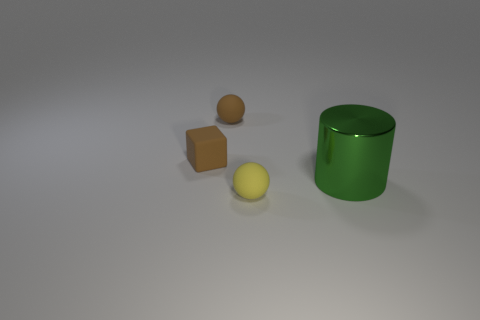What is the shape of the green metal thing?
Ensure brevity in your answer.  Cylinder. What number of blue blocks have the same size as the yellow matte thing?
Offer a terse response. 0. There is a tiny sphere that is in front of the cube; is there a matte sphere that is to the left of it?
Offer a terse response. Yes. What number of green objects are either metal cubes or balls?
Offer a very short reply. 0. What color is the big shiny thing?
Your response must be concise. Green. The brown object that is made of the same material as the small brown sphere is what size?
Ensure brevity in your answer.  Small. How many small brown matte objects have the same shape as the green shiny object?
Give a very brief answer. 0. Are there any other things that are the same size as the metal thing?
Keep it short and to the point. No. There is a cylinder in front of the brown rubber sphere behind the small yellow rubber ball; how big is it?
Ensure brevity in your answer.  Large. What is the material of the brown sphere that is the same size as the yellow object?
Give a very brief answer. Rubber. 